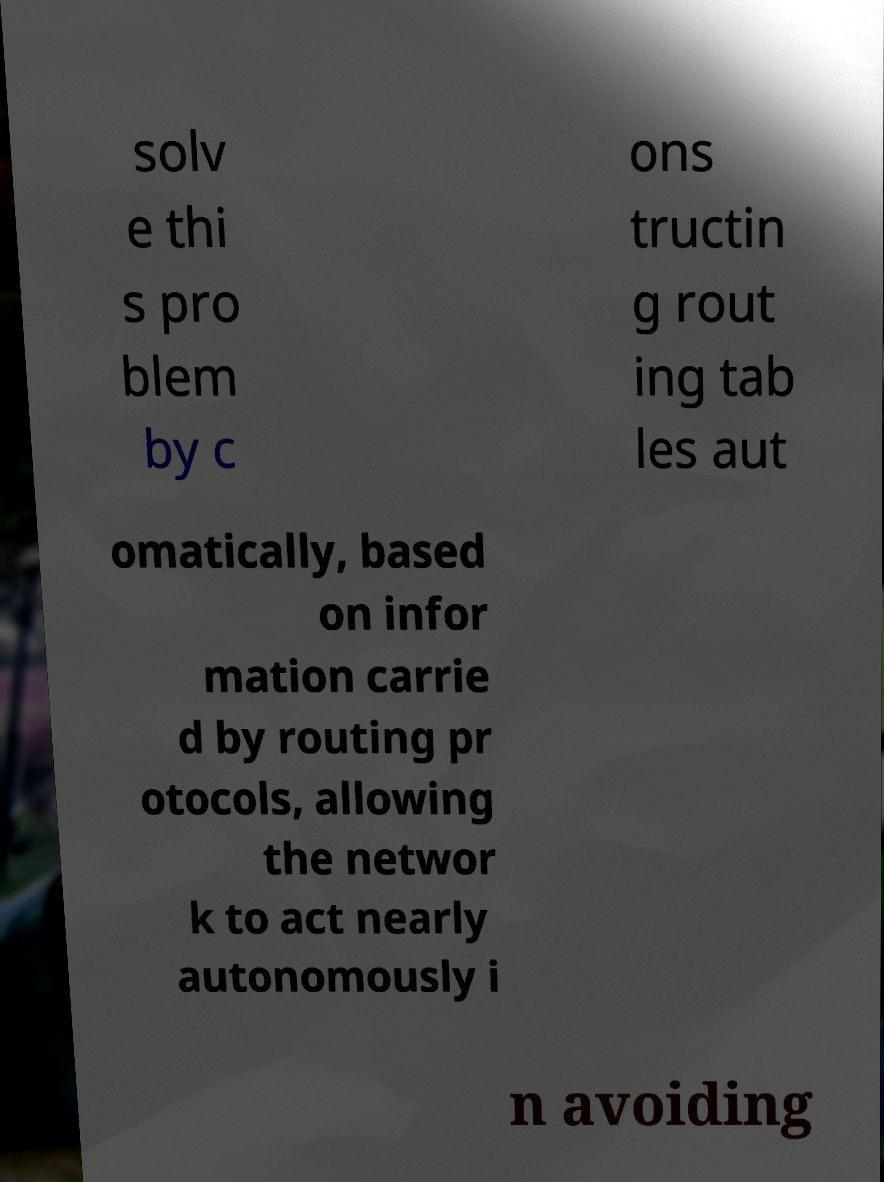Please read and relay the text visible in this image. What does it say? solv e thi s pro blem by c ons tructin g rout ing tab les aut omatically, based on infor mation carrie d by routing pr otocols, allowing the networ k to act nearly autonomously i n avoiding 